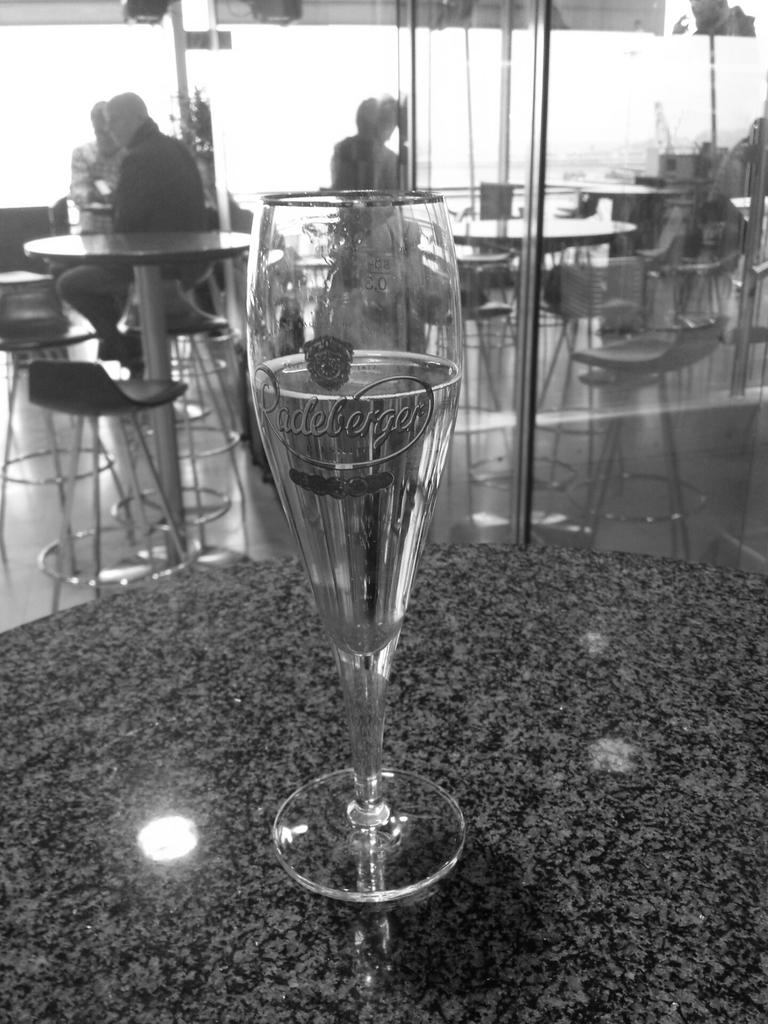What piece of furniture is present in the image? There is a table in the image. What object is placed on the table? There is a glass on the table. How many people are sitting around the table? There are people sitting on chairs around the table. What type of pizzas are being sorted by the people in the image? There is no mention of pizzas or sorting in the image; it only shows a table, a glass, and people sitting around the table. 